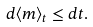<formula> <loc_0><loc_0><loc_500><loc_500>d \langle m \rangle _ { t } \leq d t .</formula> 